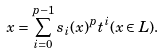Convert formula to latex. <formula><loc_0><loc_0><loc_500><loc_500>x = \sum _ { i = 0 } ^ { p - 1 } s _ { i } ( x ) ^ { p } t ^ { i } ( x \in L ) .</formula> 